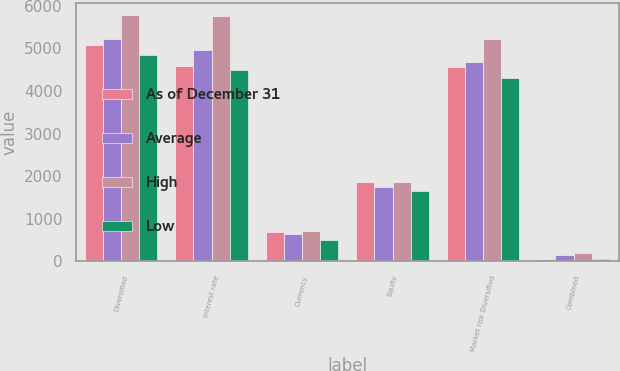Convert chart. <chart><loc_0><loc_0><loc_500><loc_500><stacked_bar_chart><ecel><fcel>Diversified<fcel>Interest rate<fcel>Currency<fcel>Equity<fcel>Market risk Diversified<fcel>Combined<nl><fcel>As of December 31<fcel>5073<fcel>4577<fcel>686<fcel>1873<fcel>4574<fcel>64<nl><fcel>Average<fcel>5209<fcel>4962<fcel>641<fcel>1754<fcel>4672<fcel>144<nl><fcel>High<fcel>5783<fcel>5765<fcel>707<fcel>1873<fcel>5224<fcel>190<nl><fcel>Low<fcel>4852<fcel>4498<fcel>509<fcel>1650<fcel>4307<fcel>64<nl></chart> 